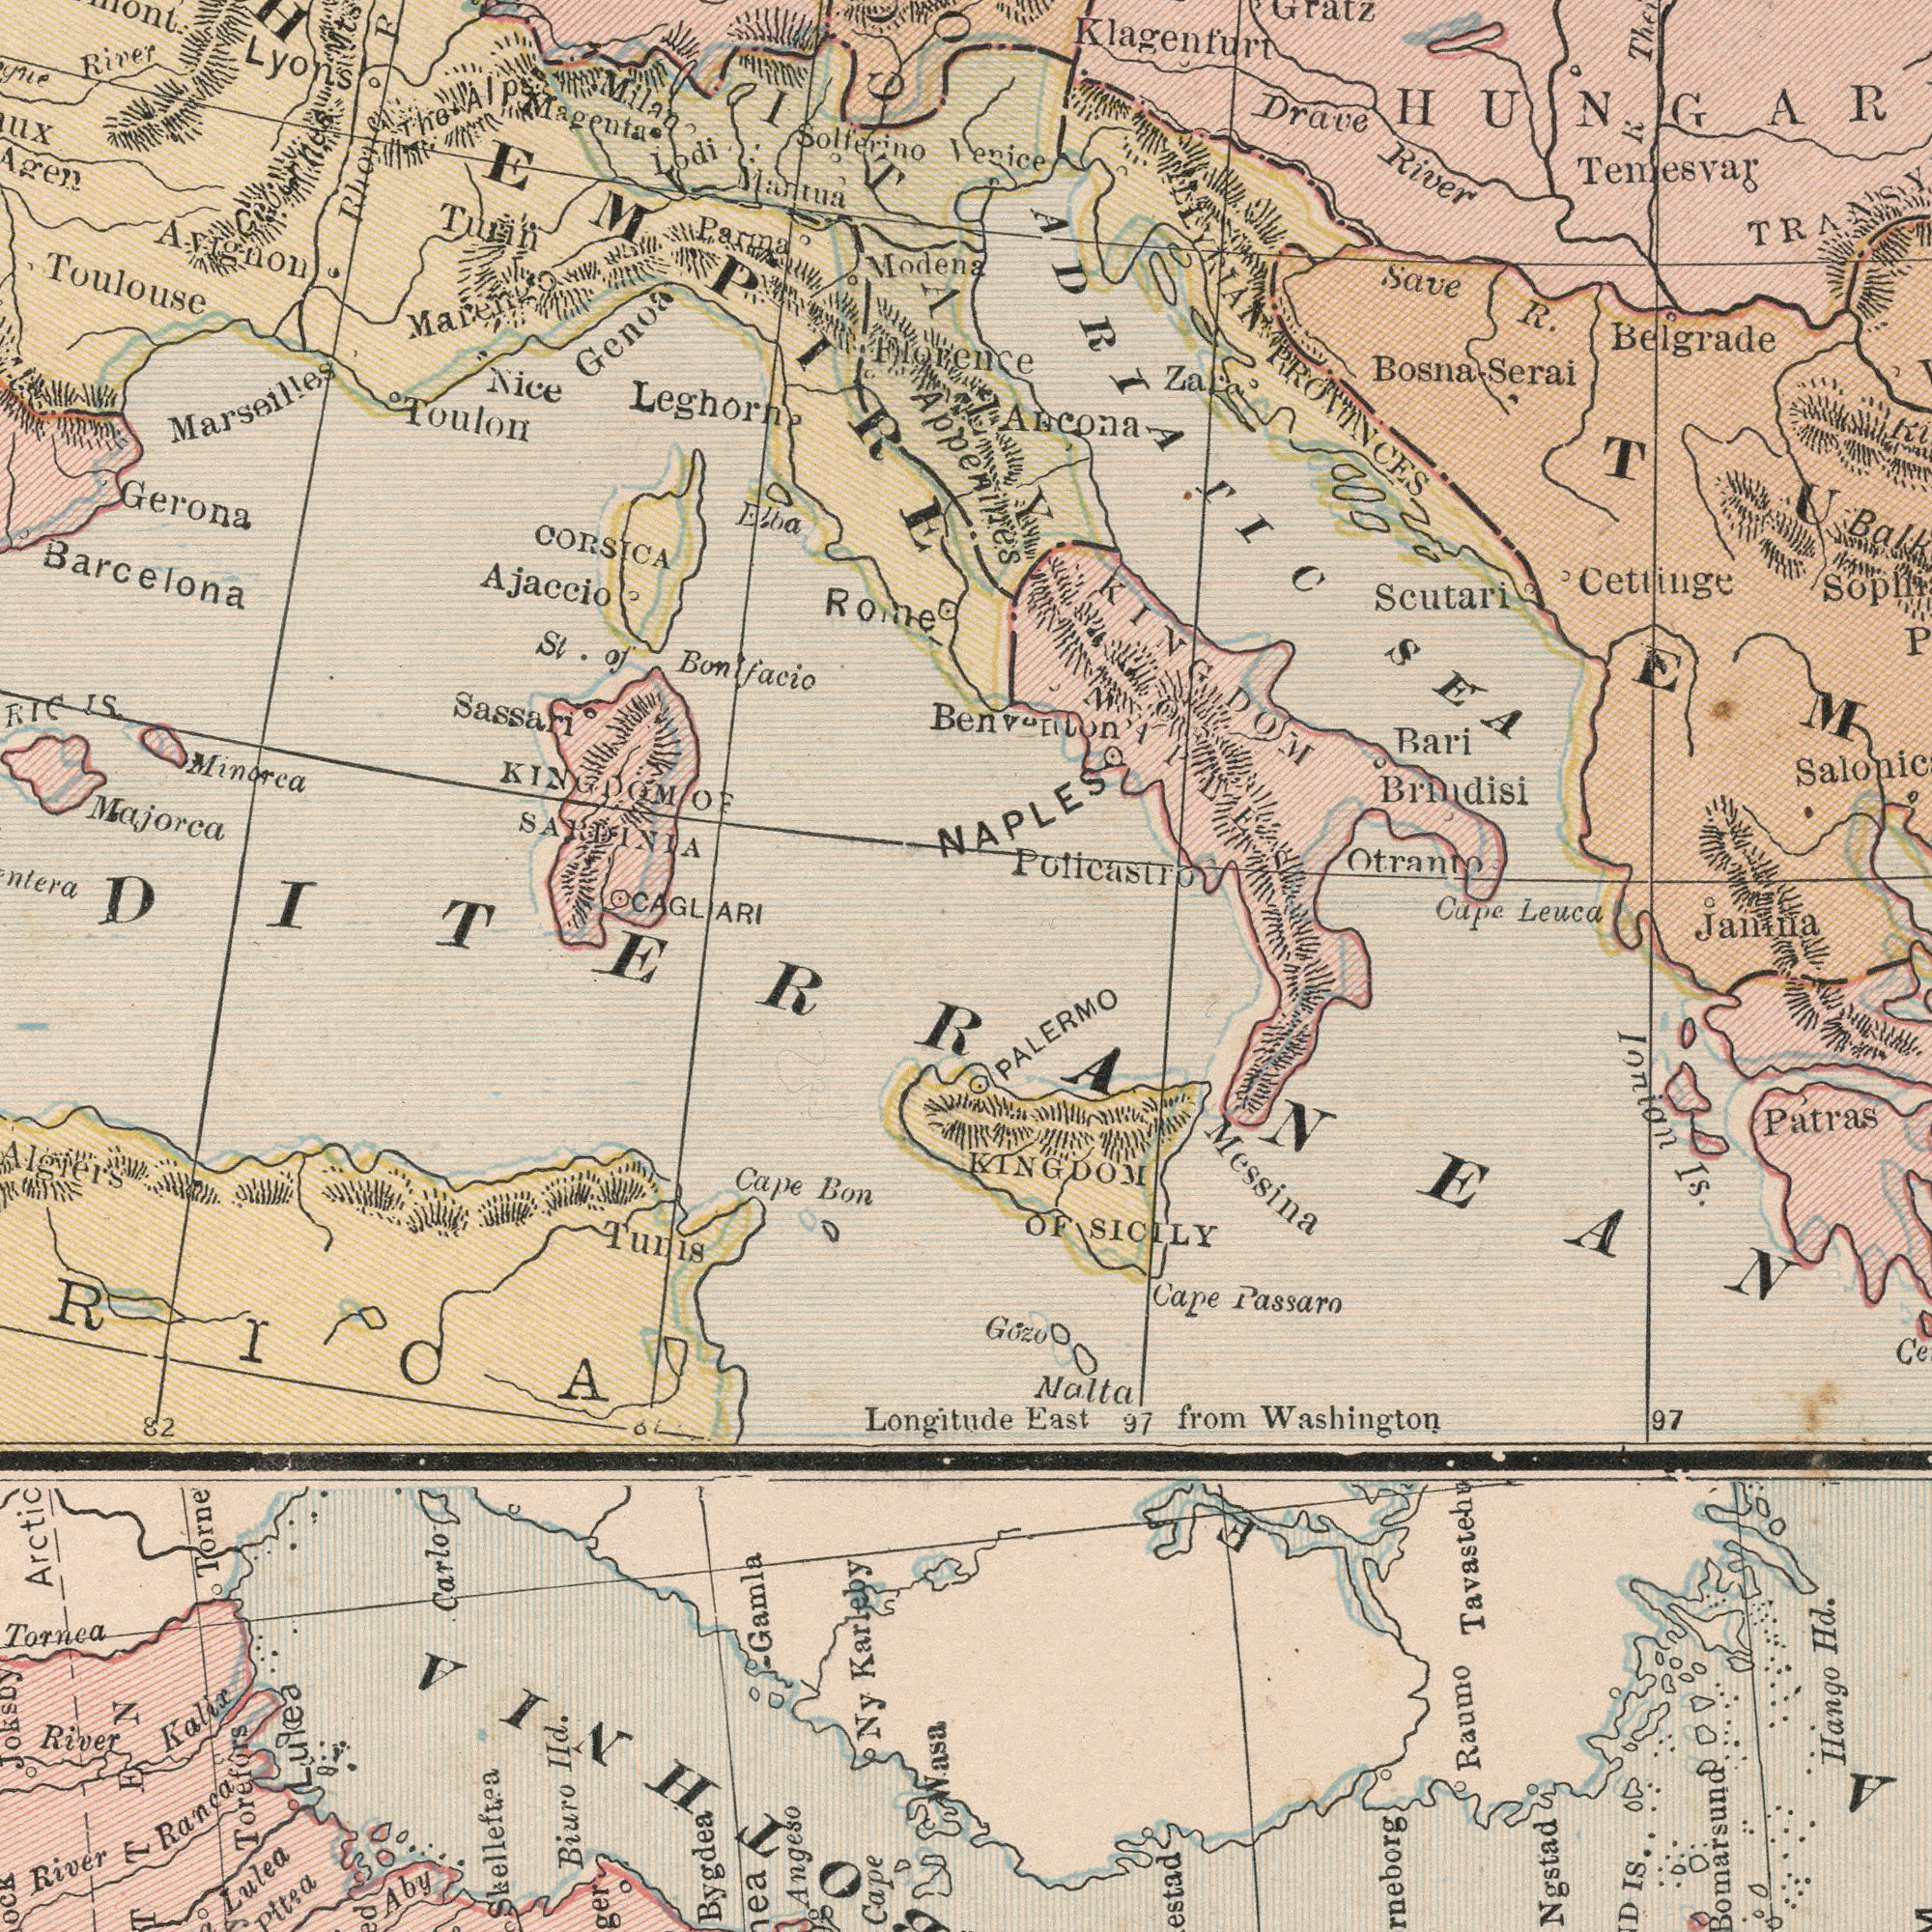What text is visible in the upper-left corner? KINGDOM OF SARDINIA Solferino Mantua River Gerona Sassari St. of Bonlfacio CORSICA Majorca Genoa Magenta Turin Minorca Modena Toulon Nice Leghorn Rome Marseilles Agen Parma Ajaccio Milan RIC IS. Lodi Toulouse Avignon Marengo CAGLIARI Elba The Alps Rhonc Mts Florence EMPIRE ITALY Lyons ##ux Barcelona What text is visible in the lower-right corner? East from Washington Ionion Is. Messina Ngstad PALERMO Patras Hango Hd. Tavastehu Nalta Gozo Cape Passaro Bomarsund 97 IS 97 OF SICILY KINGDOM A F Raumo What text appears in the top-right area of the image? Venice R. Belgrade Temesvar Bari Brindisi Janina Cettinge Drave River Klagenfurt Save R Cape Leuca Scutari Zara KINGDOM OF NAPLES Otranto Ancona ILLYRIAN PROVINCES Bosna Serai Gratz Poticastro TRANSY ADRIATIC SEA NAPLES Benventon Appenines What text can you see in the bottom-left section? Ny Karleby Torne Biuro IId. Tunis River Ranca Gamla Tornea River Kalix Skelleftea Lulea Pitea Angeso Cape Cape Bon Bygdea Torefors Carlo Aby Longitude Arctic 82 Joksoy Algiers Wasa & Lulea ###RICA ###DITERRANEAN 